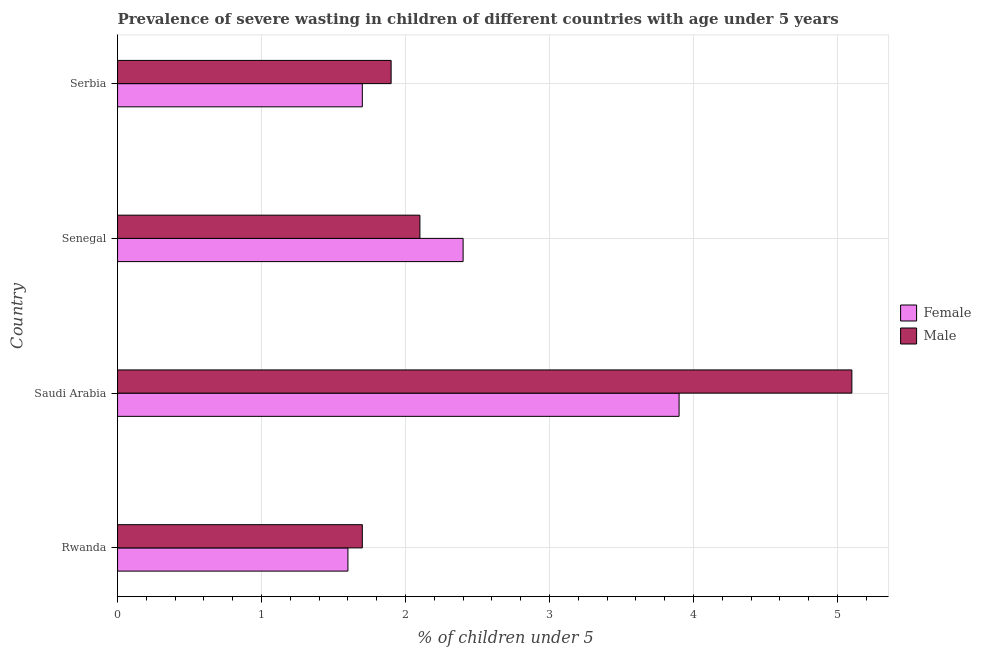How many different coloured bars are there?
Keep it short and to the point. 2. How many groups of bars are there?
Provide a short and direct response. 4. How many bars are there on the 2nd tick from the top?
Provide a short and direct response. 2. What is the label of the 1st group of bars from the top?
Offer a very short reply. Serbia. What is the percentage of undernourished female children in Serbia?
Your answer should be very brief. 1.7. Across all countries, what is the maximum percentage of undernourished female children?
Your answer should be compact. 3.9. Across all countries, what is the minimum percentage of undernourished male children?
Make the answer very short. 1.7. In which country was the percentage of undernourished female children maximum?
Offer a terse response. Saudi Arabia. In which country was the percentage of undernourished female children minimum?
Your answer should be very brief. Rwanda. What is the total percentage of undernourished male children in the graph?
Offer a terse response. 10.8. What is the difference between the percentage of undernourished male children in Saudi Arabia and that in Senegal?
Keep it short and to the point. 3. What is the difference between the percentage of undernourished male children in Serbia and the percentage of undernourished female children in Rwanda?
Your response must be concise. 0.3. What is the average percentage of undernourished male children per country?
Offer a very short reply. 2.7. What is the difference between the percentage of undernourished male children and percentage of undernourished female children in Rwanda?
Keep it short and to the point. 0.1. In how many countries, is the percentage of undernourished female children greater than 3.6 %?
Ensure brevity in your answer.  1. What is the ratio of the percentage of undernourished male children in Rwanda to that in Serbia?
Your response must be concise. 0.9. Is the percentage of undernourished male children in Rwanda less than that in Senegal?
Ensure brevity in your answer.  Yes. Is the difference between the percentage of undernourished female children in Saudi Arabia and Serbia greater than the difference between the percentage of undernourished male children in Saudi Arabia and Serbia?
Your answer should be compact. No. What is the difference between the highest and the second highest percentage of undernourished male children?
Make the answer very short. 3. What does the 1st bar from the top in Serbia represents?
Give a very brief answer. Male. How many bars are there?
Offer a very short reply. 8. Where does the legend appear in the graph?
Provide a succinct answer. Center right. How many legend labels are there?
Offer a very short reply. 2. What is the title of the graph?
Your answer should be very brief. Prevalence of severe wasting in children of different countries with age under 5 years. Does "Death rate" appear as one of the legend labels in the graph?
Provide a short and direct response. No. What is the label or title of the X-axis?
Provide a succinct answer.  % of children under 5. What is the label or title of the Y-axis?
Keep it short and to the point. Country. What is the  % of children under 5 of Female in Rwanda?
Keep it short and to the point. 1.6. What is the  % of children under 5 in Male in Rwanda?
Give a very brief answer. 1.7. What is the  % of children under 5 of Female in Saudi Arabia?
Your answer should be compact. 3.9. What is the  % of children under 5 in Male in Saudi Arabia?
Make the answer very short. 5.1. What is the  % of children under 5 in Female in Senegal?
Your answer should be very brief. 2.4. What is the  % of children under 5 of Male in Senegal?
Offer a very short reply. 2.1. What is the  % of children under 5 in Female in Serbia?
Give a very brief answer. 1.7. What is the  % of children under 5 in Male in Serbia?
Offer a terse response. 1.9. Across all countries, what is the maximum  % of children under 5 in Female?
Ensure brevity in your answer.  3.9. Across all countries, what is the maximum  % of children under 5 in Male?
Offer a very short reply. 5.1. Across all countries, what is the minimum  % of children under 5 in Female?
Provide a short and direct response. 1.6. Across all countries, what is the minimum  % of children under 5 of Male?
Offer a terse response. 1.7. What is the total  % of children under 5 of Female in the graph?
Offer a very short reply. 9.6. What is the difference between the  % of children under 5 in Female in Rwanda and that in Saudi Arabia?
Your response must be concise. -2.3. What is the difference between the  % of children under 5 in Male in Rwanda and that in Saudi Arabia?
Provide a succinct answer. -3.4. What is the difference between the  % of children under 5 of Female in Saudi Arabia and that in Serbia?
Offer a terse response. 2.2. What is the difference between the  % of children under 5 of Female in Senegal and that in Serbia?
Your answer should be compact. 0.7. What is the difference between the  % of children under 5 of Male in Senegal and that in Serbia?
Your response must be concise. 0.2. What is the difference between the  % of children under 5 in Female in Rwanda and the  % of children under 5 in Male in Saudi Arabia?
Ensure brevity in your answer.  -3.5. What is the difference between the  % of children under 5 of Female in Rwanda and the  % of children under 5 of Male in Senegal?
Ensure brevity in your answer.  -0.5. What is the difference between the  % of children under 5 of Female in Saudi Arabia and the  % of children under 5 of Male in Senegal?
Provide a succinct answer. 1.8. What is the difference between the  % of children under 5 of Female in Saudi Arabia and the  % of children under 5 of Male in Serbia?
Give a very brief answer. 2. What is the difference between the  % of children under 5 of Female and  % of children under 5 of Male in Saudi Arabia?
Keep it short and to the point. -1.2. What is the ratio of the  % of children under 5 in Female in Rwanda to that in Saudi Arabia?
Make the answer very short. 0.41. What is the ratio of the  % of children under 5 of Male in Rwanda to that in Saudi Arabia?
Provide a short and direct response. 0.33. What is the ratio of the  % of children under 5 of Female in Rwanda to that in Senegal?
Give a very brief answer. 0.67. What is the ratio of the  % of children under 5 in Male in Rwanda to that in Senegal?
Provide a short and direct response. 0.81. What is the ratio of the  % of children under 5 of Female in Rwanda to that in Serbia?
Your answer should be very brief. 0.94. What is the ratio of the  % of children under 5 of Male in Rwanda to that in Serbia?
Make the answer very short. 0.89. What is the ratio of the  % of children under 5 in Female in Saudi Arabia to that in Senegal?
Offer a very short reply. 1.62. What is the ratio of the  % of children under 5 in Male in Saudi Arabia to that in Senegal?
Provide a short and direct response. 2.43. What is the ratio of the  % of children under 5 of Female in Saudi Arabia to that in Serbia?
Your answer should be very brief. 2.29. What is the ratio of the  % of children under 5 of Male in Saudi Arabia to that in Serbia?
Give a very brief answer. 2.68. What is the ratio of the  % of children under 5 of Female in Senegal to that in Serbia?
Offer a very short reply. 1.41. What is the ratio of the  % of children under 5 in Male in Senegal to that in Serbia?
Give a very brief answer. 1.11. What is the difference between the highest and the lowest  % of children under 5 of Female?
Ensure brevity in your answer.  2.3. 